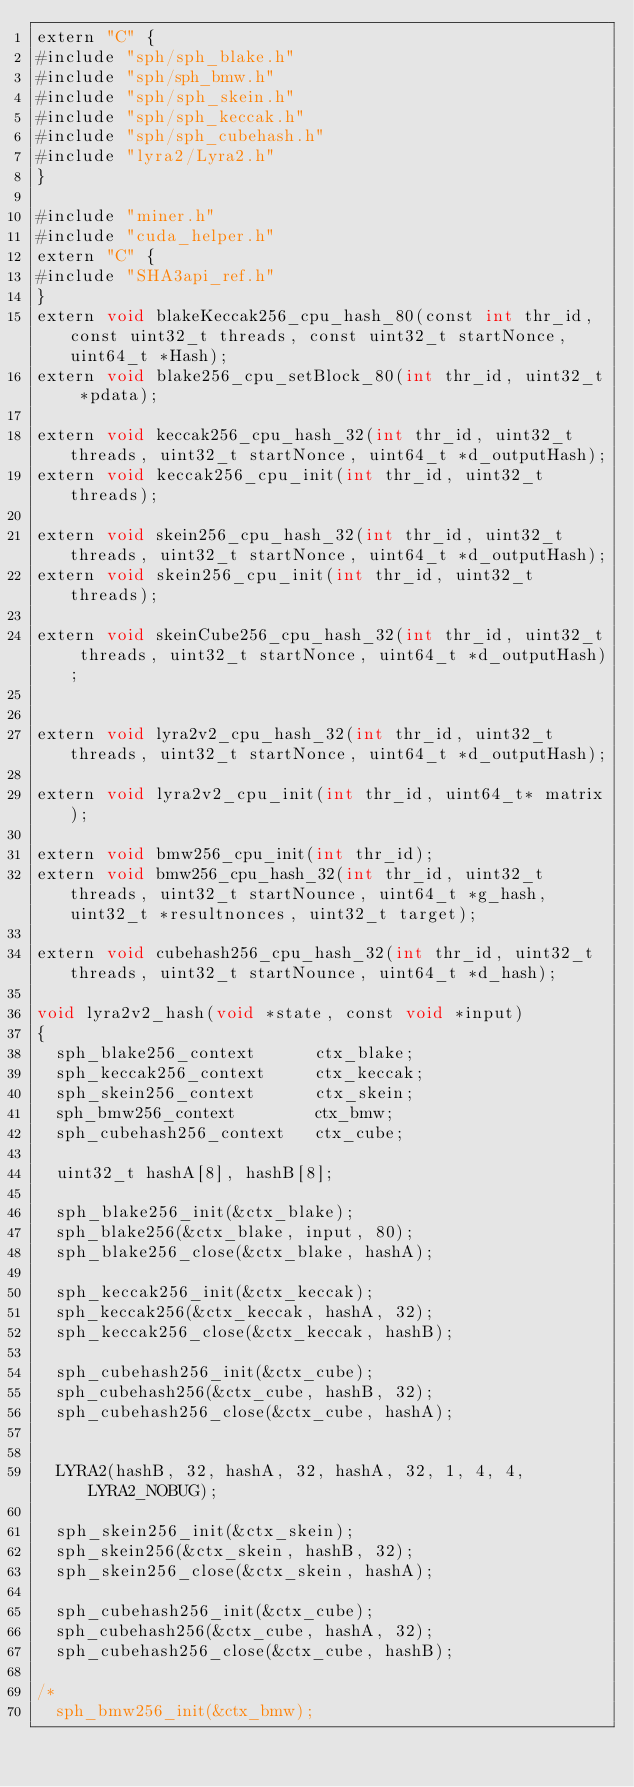Convert code to text. <code><loc_0><loc_0><loc_500><loc_500><_Cuda_>extern "C" {
#include "sph/sph_blake.h"
#include "sph/sph_bmw.h"
#include "sph/sph_skein.h"
#include "sph/sph_keccak.h"
#include "sph/sph_cubehash.h"
#include "lyra2/Lyra2.h"
}

#include "miner.h"
#include "cuda_helper.h"
extern "C" {
#include "SHA3api_ref.h"
}
extern void blakeKeccak256_cpu_hash_80(const int thr_id, const uint32_t threads, const uint32_t startNonce, uint64_t *Hash);
extern void blake256_cpu_setBlock_80(int thr_id, uint32_t *pdata);

extern void keccak256_cpu_hash_32(int thr_id, uint32_t threads, uint32_t startNonce, uint64_t *d_outputHash);
extern void keccak256_cpu_init(int thr_id, uint32_t threads);

extern void skein256_cpu_hash_32(int thr_id, uint32_t threads, uint32_t startNonce, uint64_t *d_outputHash);
extern void skein256_cpu_init(int thr_id, uint32_t threads);

extern void skeinCube256_cpu_hash_32(int thr_id, uint32_t threads, uint32_t startNonce, uint64_t *d_outputHash);


extern void lyra2v2_cpu_hash_32(int thr_id, uint32_t threads, uint32_t startNonce, uint64_t *d_outputHash);

extern void lyra2v2_cpu_init(int thr_id, uint64_t* matrix);

extern void bmw256_cpu_init(int thr_id);
extern void bmw256_cpu_hash_32(int thr_id, uint32_t threads, uint32_t startNounce, uint64_t *g_hash, uint32_t *resultnonces, uint32_t target);

extern void cubehash256_cpu_hash_32(int thr_id, uint32_t threads, uint32_t startNounce, uint64_t *d_hash);

void lyra2v2_hash(void *state, const void *input)
{
	sph_blake256_context      ctx_blake;
	sph_keccak256_context     ctx_keccak;
	sph_skein256_context      ctx_skein;
	sph_bmw256_context        ctx_bmw;
	sph_cubehash256_context   ctx_cube;

	uint32_t hashA[8], hashB[8];

	sph_blake256_init(&ctx_blake);
	sph_blake256(&ctx_blake, input, 80);
	sph_blake256_close(&ctx_blake, hashA);

	sph_keccak256_init(&ctx_keccak);
	sph_keccak256(&ctx_keccak, hashA, 32);
	sph_keccak256_close(&ctx_keccak, hashB);

	sph_cubehash256_init(&ctx_cube);
	sph_cubehash256(&ctx_cube, hashB, 32);
	sph_cubehash256_close(&ctx_cube, hashA);


	LYRA2(hashB, 32, hashA, 32, hashA, 32, 1, 4, 4, LYRA2_NOBUG);

	sph_skein256_init(&ctx_skein);
	sph_skein256(&ctx_skein, hashB, 32);
	sph_skein256_close(&ctx_skein, hashA);

	sph_cubehash256_init(&ctx_cube);
	sph_cubehash256(&ctx_cube, hashA, 32);
	sph_cubehash256_close(&ctx_cube, hashB);

/*
	sph_bmw256_init(&ctx_bmw);</code> 